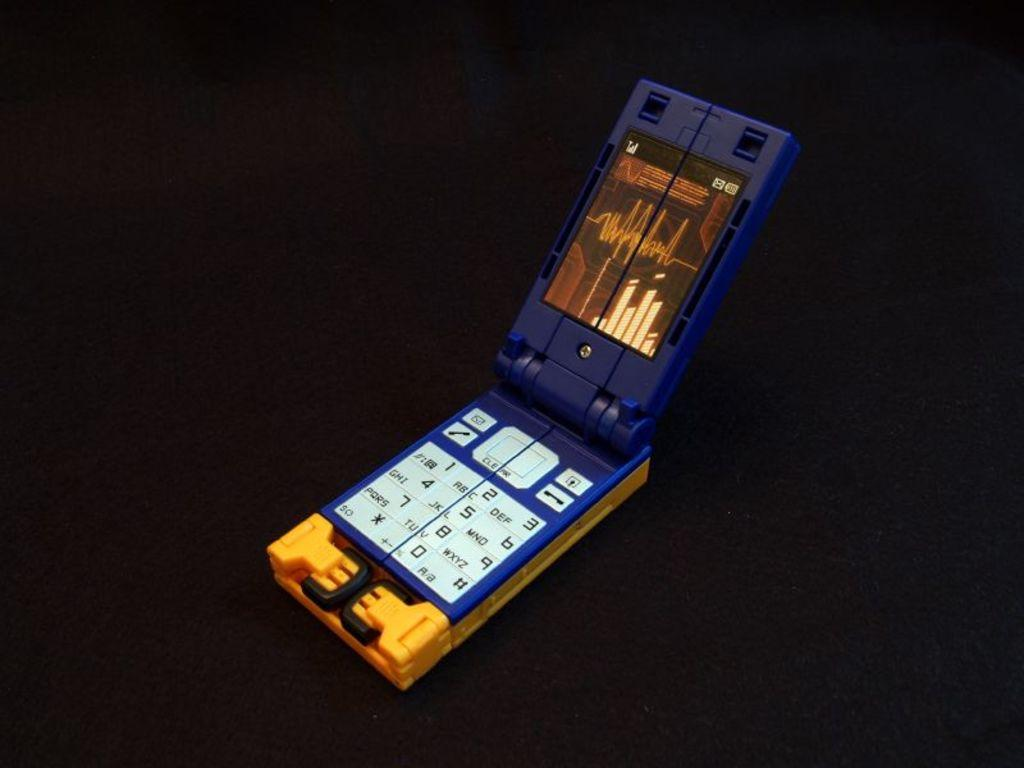<image>
Write a terse but informative summary of the picture. a squared phone has buttons for phone, mail and numbers on it 